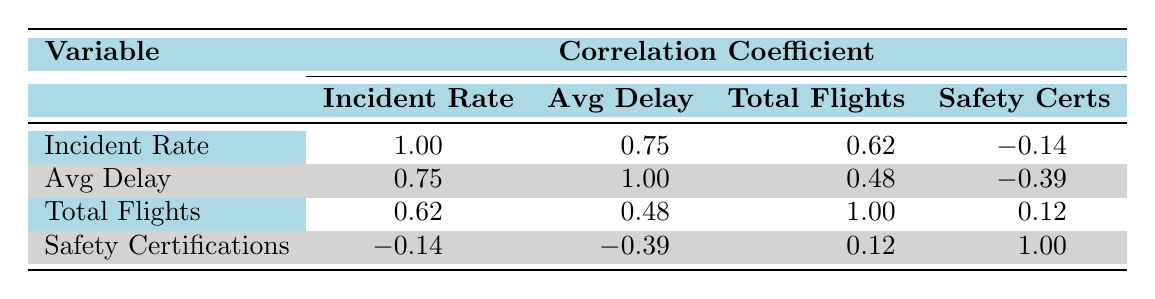What is the incident rate of Southwest Airlines? The table shows the incident rate for each airline. For Southwest Airlines, the corresponding value under the "Incident Rate" column is 0.4.
Answer: 0.4 What is the average delay time for United Airlines in minutes? The table lists data for different airlines, including their average delay times. For United Airlines, the average delay is indicated as 18 minutes.
Answer: 18 Is there a positive correlation between incident rates and average delay times? Looking at the correlation coefficients, the value between incident rates and average delay is 0.75. Since this is a positive number, it indicates a positive correlation.
Answer: Yes Which airline has the highest number of total flights, and what is that number? From the "Total Flights" column, comparing the numbers, Delta Air Lines has the highest total flights at 500,000.
Answer: Delta Air Lines, 500,000 If you were to average the incident rates of all airlines, what would that value be? The incident rates listed in the table are 0.6, 0.5, 0.7, 0.4, 0.3, and 0.5. Adding these gives 3.0, and dividing by the 6 airlines results in an average incident rate of 0.5.
Answer: 0.5 Is the correlation between safety certifications and incident rates negative? The correlation coefficient between safety certifications and incident rates is -0.14, indicating a slight negative correlation. This means that as safety certifications increase, incident rates may decrease slightly.
Answer: Yes What is the total number of flights for airlines with an incident rate below 0.5? The airlines with incident rates below 0.5 are Southwest Airlines (400,000), JetBlue Airways (250,000), and Delta Air Lines (500,000). Adding these totals gives 1,150,000 flights.
Answer: 1,150,000 Which airline has the most safety certifications, and how does it relate to its incident rate? Alaska Airlines and Delta Air Lines both have the highest number of safety certifications at 5. Alaska Airlines has an incident rate of 0.5, while Delta Air Lines has an incident rate of 0.5 as well, indicating no direct relationship of fewer incidents despite more certifications.
Answer: Alaska Airlines and Delta Air Lines, incident rates 0.5 What are the average incident rates for airlines with four safety certifications? The airlines with four safety certifications are American Airlines, United Airlines, and JetBlue Airways. Their incident rates are 0.6, 0.7, and 0.3 respectively, which sums to 1.6. Dividing by 3 gives an average incident rate of approximately 0.53.
Answer: 0.53 